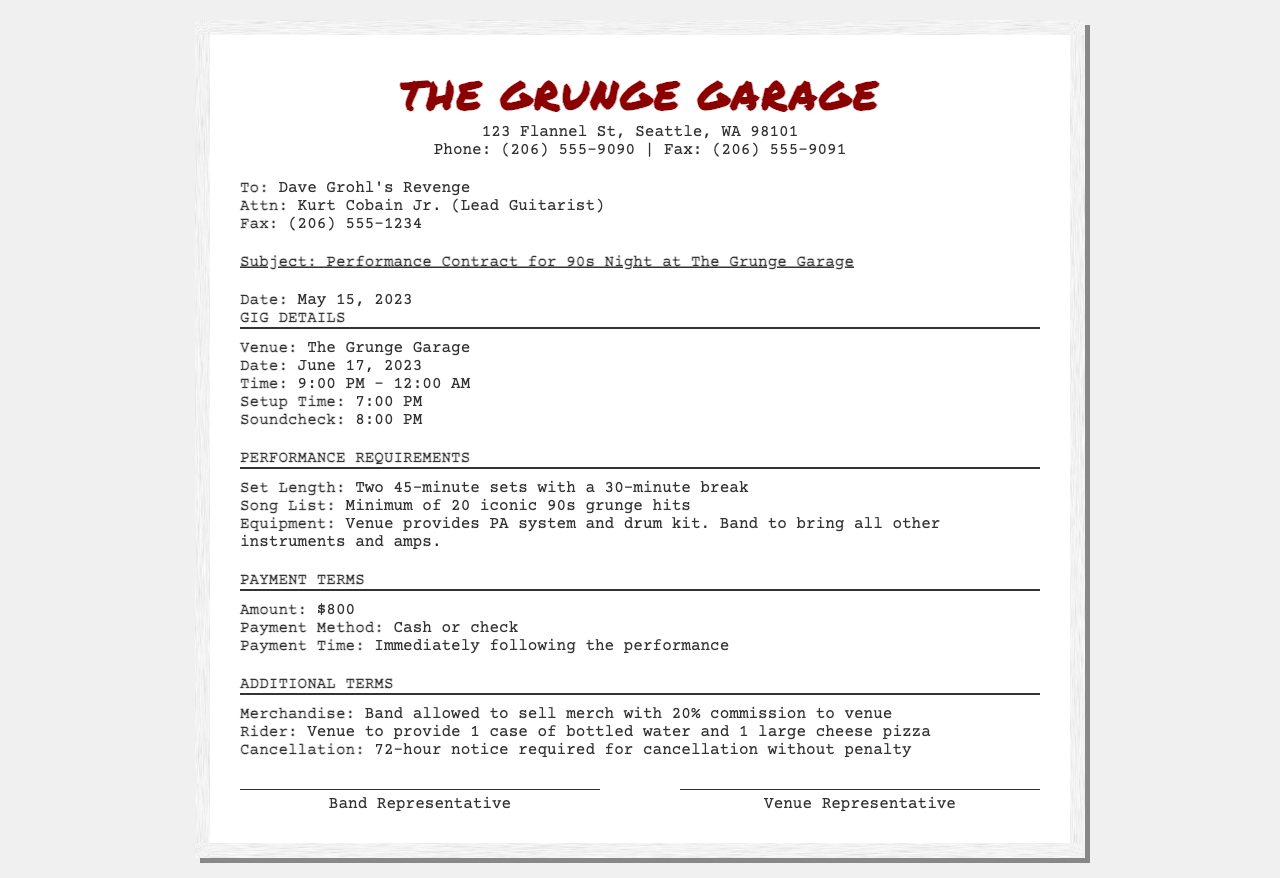What is the name of the venue? The venue for the gig is provided in the document's gig details section.
Answer: The Grunge Garage What is the performance date? The date of the performance is specified under the gig details.
Answer: June 17, 2023 What are the setup and soundcheck times? The setup and soundcheck times are both detailed in the gig details section.
Answer: 7:00 PM and 8:00 PM How long is each set? The performance requirements section specifies the length of each set.
Answer: 45 minutes What is the payment amount? The payment terms outline the amount that will be paid for the gig.
Answer: $800 What must the band provide for the performance? The performance requirements specify what equipment the band needs to bring.
Answer: All other instruments and amps What percentage of merchandise sales goes to the venue? This detail is mentioned in the additional terms section of the document.
Answer: 20% What is required for cancellation without penalty? The cancellation policy is detailed in the additional terms section.
Answer: 72-hour notice 